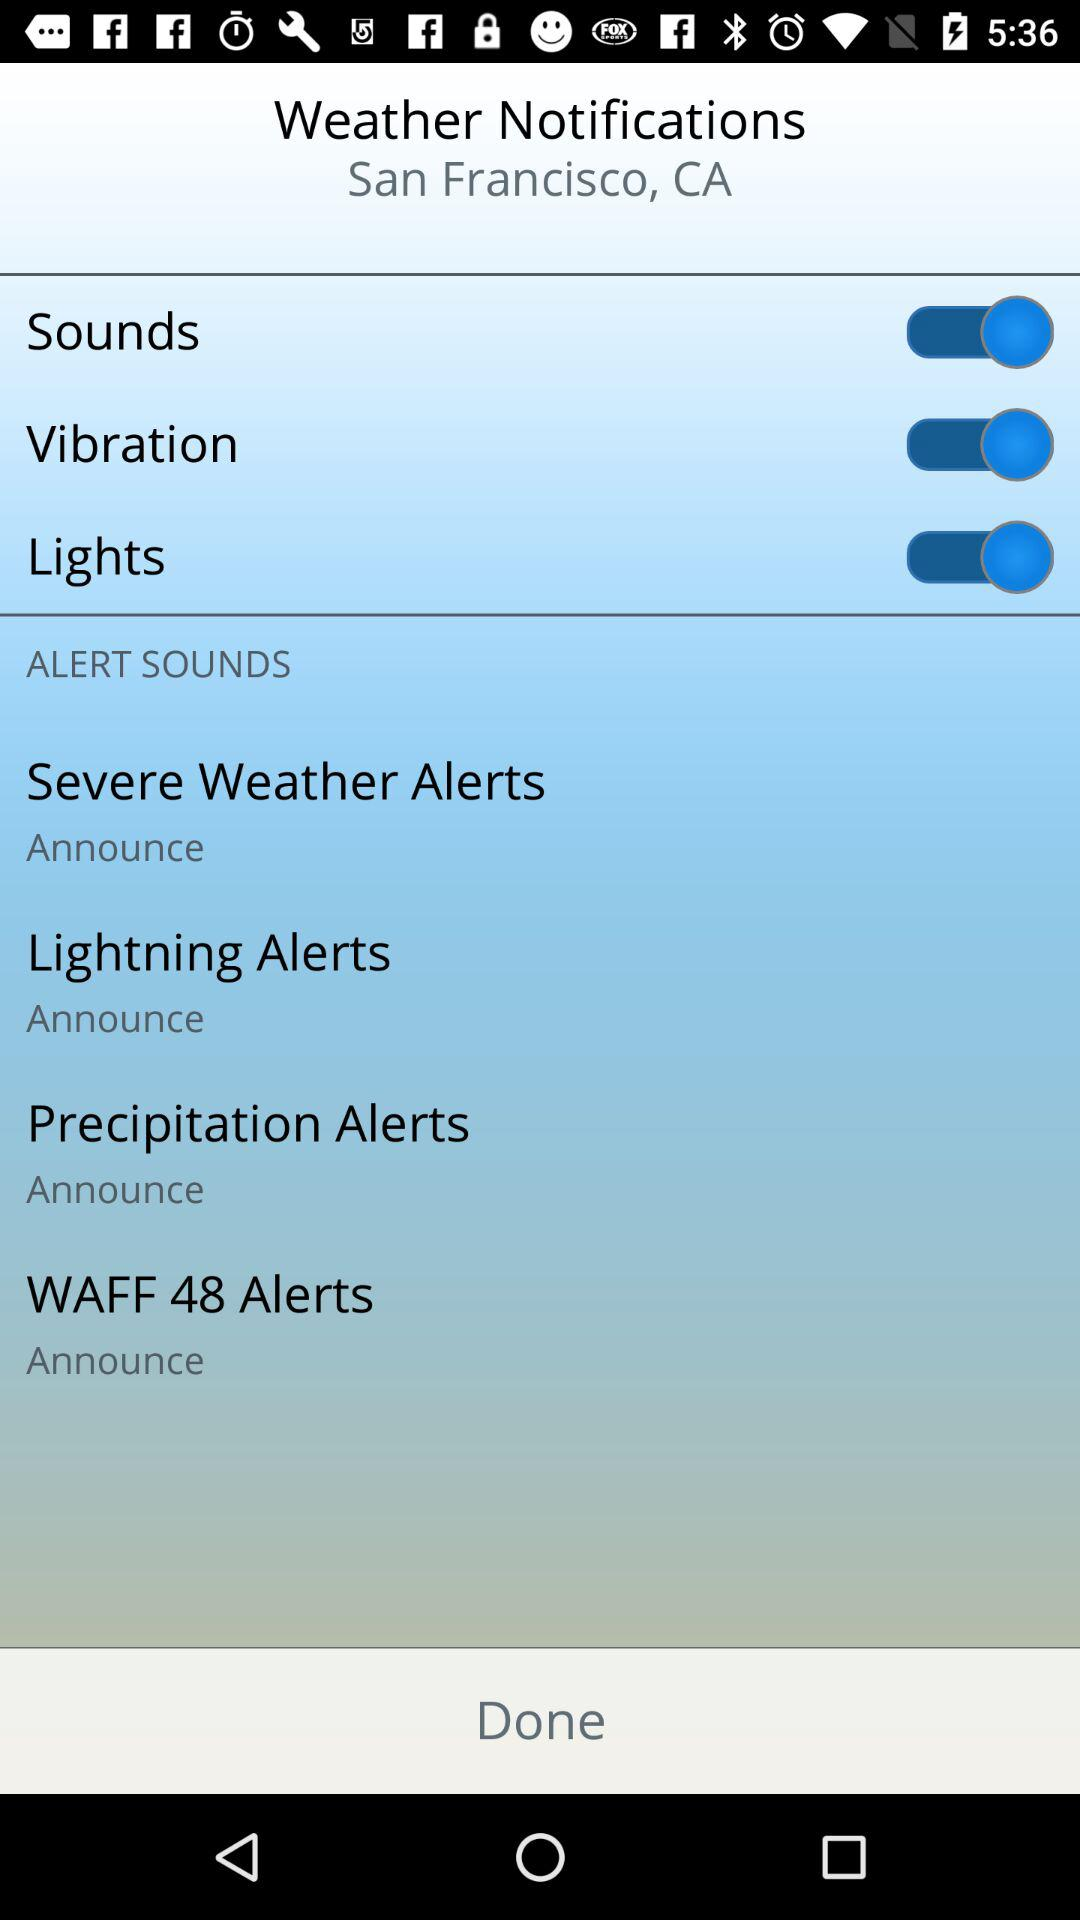What's the city name? The city name is San Francisco. 